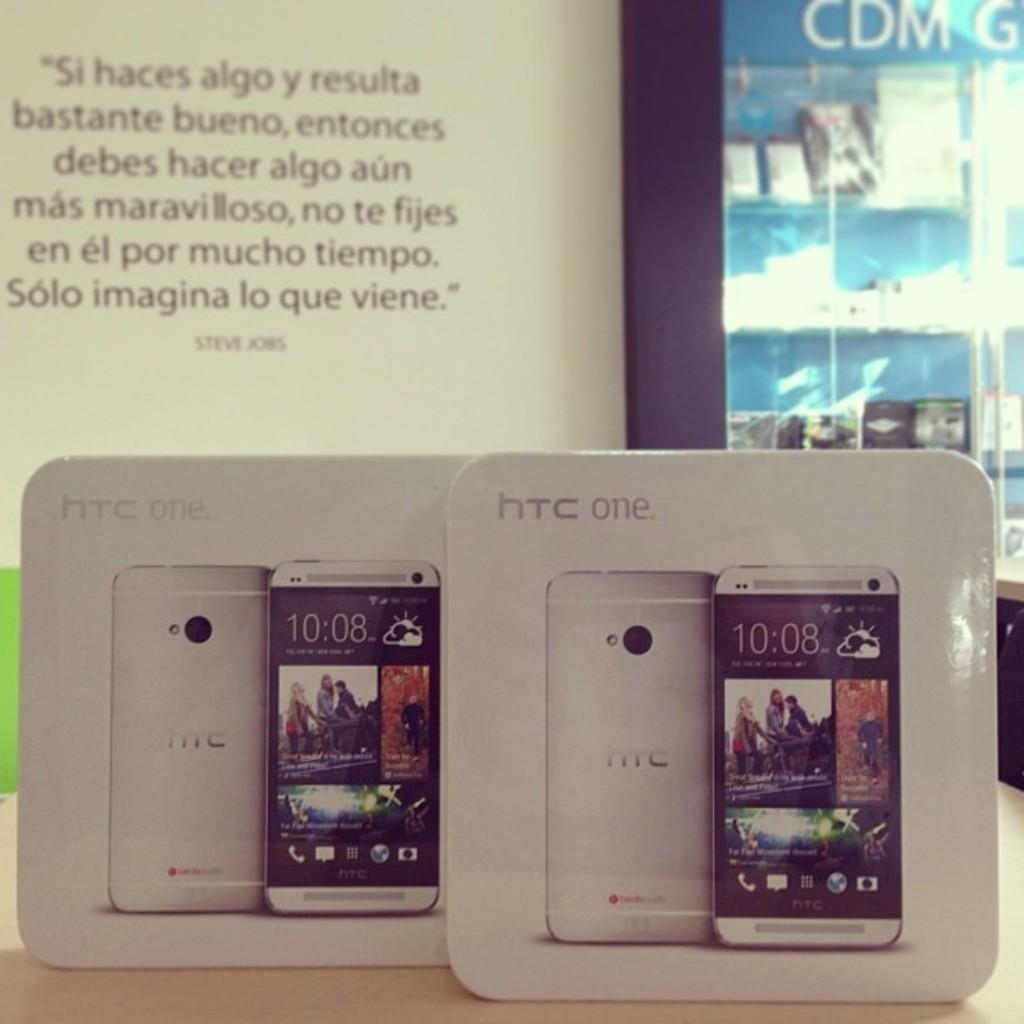<image>
Give a short and clear explanation of the subsequent image. A background in spanish with two HTC One cell phones. 